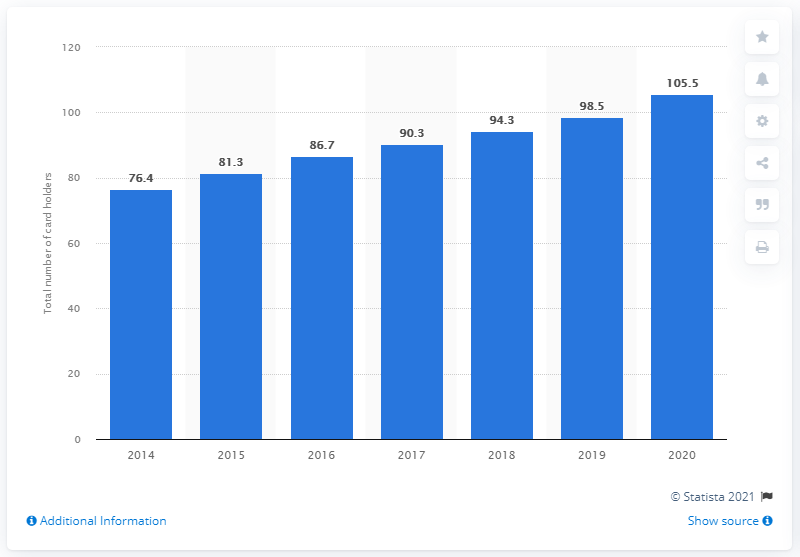Draw attention to some important aspects in this diagram. Since 2014, the number of cardholders has been steadily growing. In 2020, the number of people who paid for a yearly Costco membership was 105.5. 